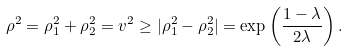<formula> <loc_0><loc_0><loc_500><loc_500>\rho ^ { 2 } = \rho _ { 1 } ^ { 2 } + \rho _ { 2 } ^ { 2 } = v ^ { 2 } \geq | \rho _ { 1 } ^ { 2 } - \rho _ { 2 } ^ { 2 } | = \exp \left ( \frac { 1 - \lambda } { 2 \lambda } \right ) .</formula> 